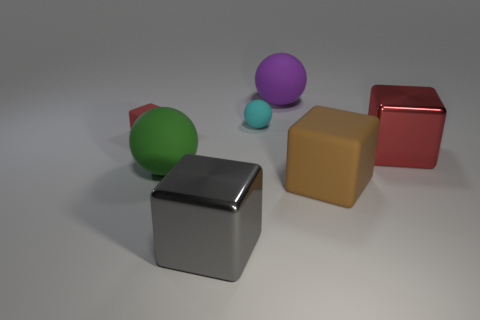Is the color of the tiny cube the same as the matte cube on the right side of the big green rubber sphere?
Offer a terse response. No. The other metallic thing that is the same shape as the big gray metallic object is what size?
Keep it short and to the point. Large. What is the shape of the rubber object that is to the left of the tiny cyan matte thing and on the right side of the small red rubber thing?
Make the answer very short. Sphere. There is a brown cube; does it have the same size as the rubber sphere in front of the big red metal block?
Keep it short and to the point. Yes. What color is the other metallic object that is the same shape as the gray thing?
Provide a succinct answer. Red. There is a red cube that is left of the brown rubber object; is it the same size as the metallic cube that is in front of the red metal object?
Keep it short and to the point. No. Is the tiny red object the same shape as the gray thing?
Make the answer very short. Yes. How many things are either matte objects right of the tiny red rubber object or large balls?
Offer a very short reply. 4. Is there another small object of the same shape as the green thing?
Ensure brevity in your answer.  Yes. Are there the same number of green matte things right of the purple sphere and gray cubes?
Make the answer very short. No. 